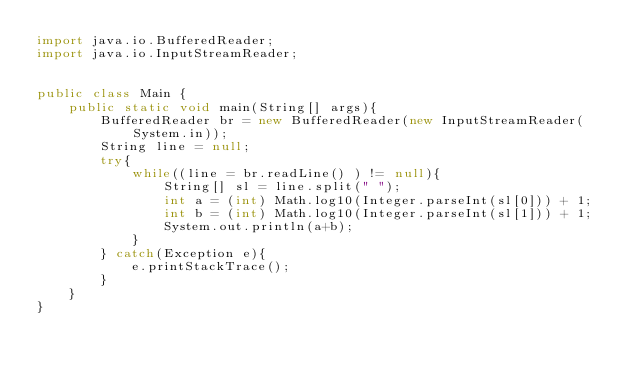<code> <loc_0><loc_0><loc_500><loc_500><_Java_>import java.io.BufferedReader;
import java.io.InputStreamReader;


public class Main {
	public static void main(String[] args){
		BufferedReader br = new BufferedReader(new InputStreamReader(System.in));
		String line = null;
		try{
			while((line = br.readLine() ) != null){
				String[] sl = line.split(" ");
				int a = (int) Math.log10(Integer.parseInt(sl[0])) + 1;
				int b = (int) Math.log10(Integer.parseInt(sl[1])) + 1;
				System.out.println(a+b);
			}
		} catch(Exception e){
			e.printStackTrace();
		}
	}
}</code> 